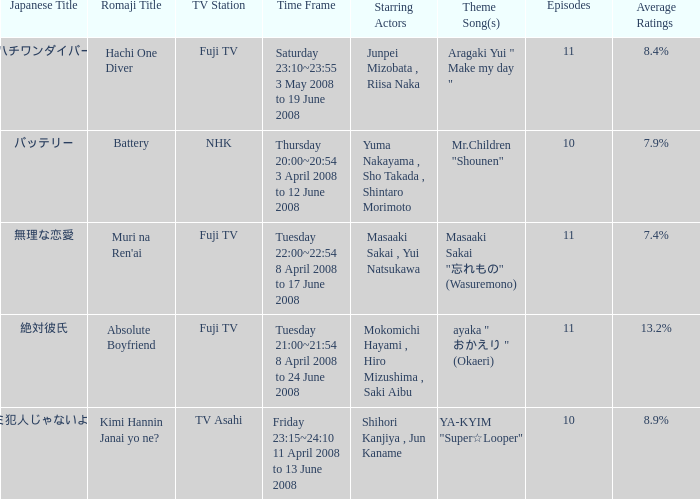How many titles had an average rating of 8.9%? 1.0. 